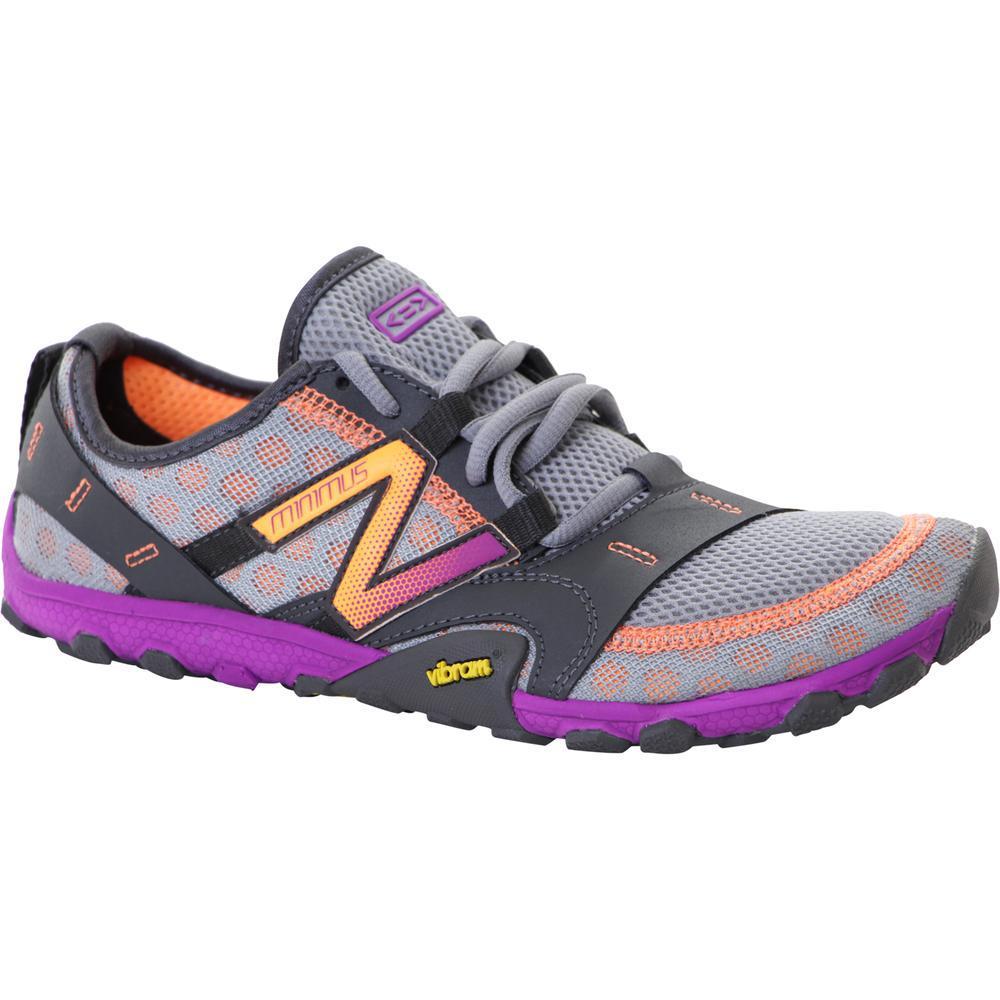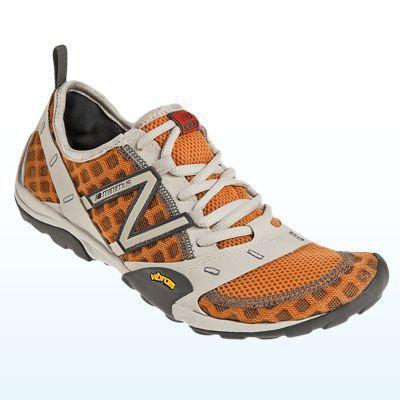The first image is the image on the left, the second image is the image on the right. Given the left and right images, does the statement "In total, two pairs of sneakers are shown." hold true? Answer yes or no. No. 